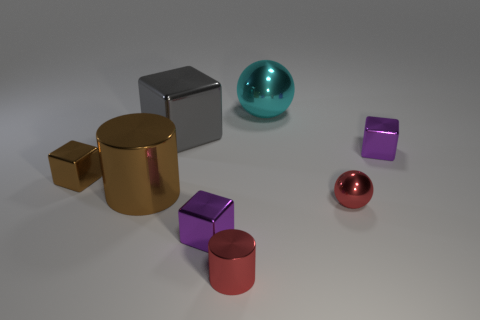There is a brown shiny object that is the same shape as the gray metal thing; what is its size?
Ensure brevity in your answer.  Small. Are there any big cylinders of the same color as the small metal cylinder?
Your answer should be compact. No. What material is the thing that is the same color as the small metal cylinder?
Ensure brevity in your answer.  Metal. How many tiny cylinders have the same color as the tiny ball?
Your answer should be compact. 1. How many objects are small metallic things in front of the tiny brown block or tiny cylinders?
Offer a terse response. 3. There is a large cylinder that is the same material as the small sphere; what is its color?
Give a very brief answer. Brown. Are there any cyan balls of the same size as the red metal cylinder?
Your answer should be compact. No. How many objects are purple shiny things in front of the small brown object or cubes on the left side of the cyan sphere?
Offer a very short reply. 3. What is the shape of the brown metal object that is the same size as the cyan metallic thing?
Keep it short and to the point. Cylinder. Is there a small brown metal object of the same shape as the gray metal thing?
Offer a very short reply. Yes. 